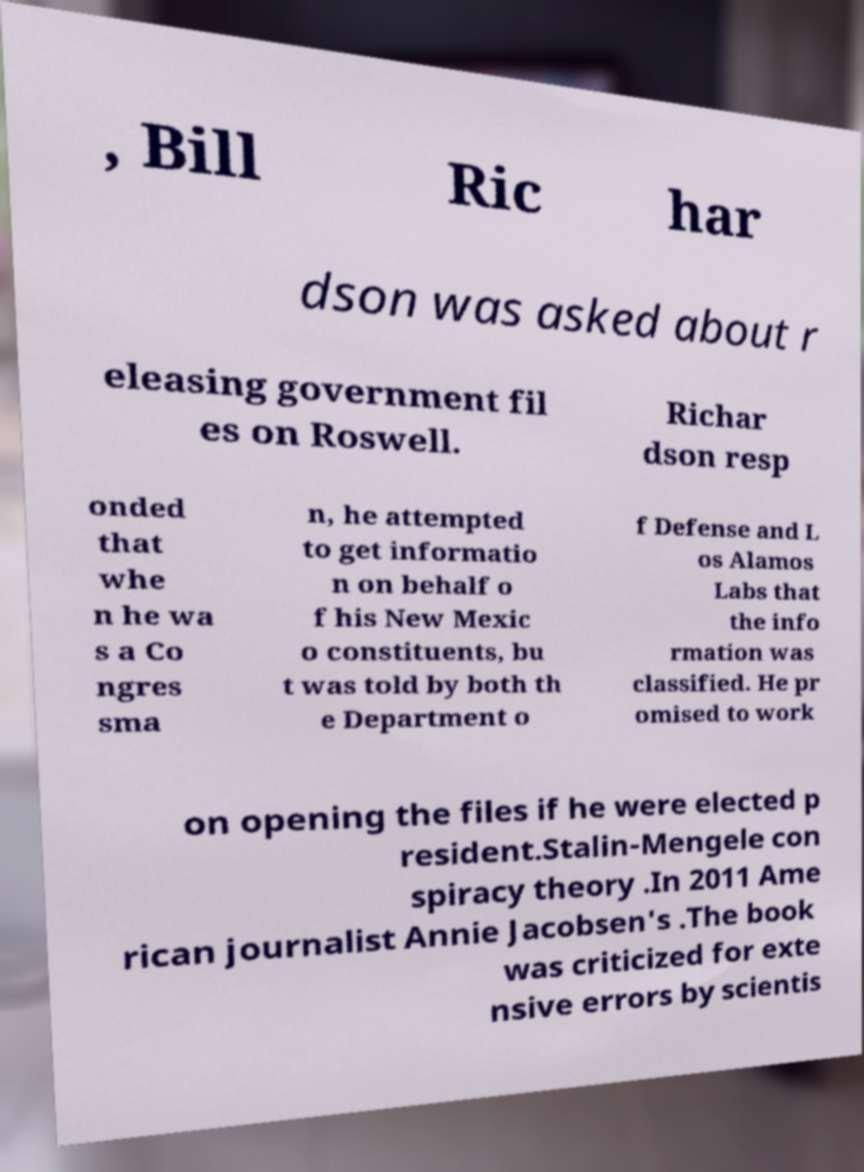Could you extract and type out the text from this image? , Bill Ric har dson was asked about r eleasing government fil es on Roswell. Richar dson resp onded that whe n he wa s a Co ngres sma n, he attempted to get informatio n on behalf o f his New Mexic o constituents, bu t was told by both th e Department o f Defense and L os Alamos Labs that the info rmation was classified. He pr omised to work on opening the files if he were elected p resident.Stalin-Mengele con spiracy theory .In 2011 Ame rican journalist Annie Jacobsen's .The book was criticized for exte nsive errors by scientis 